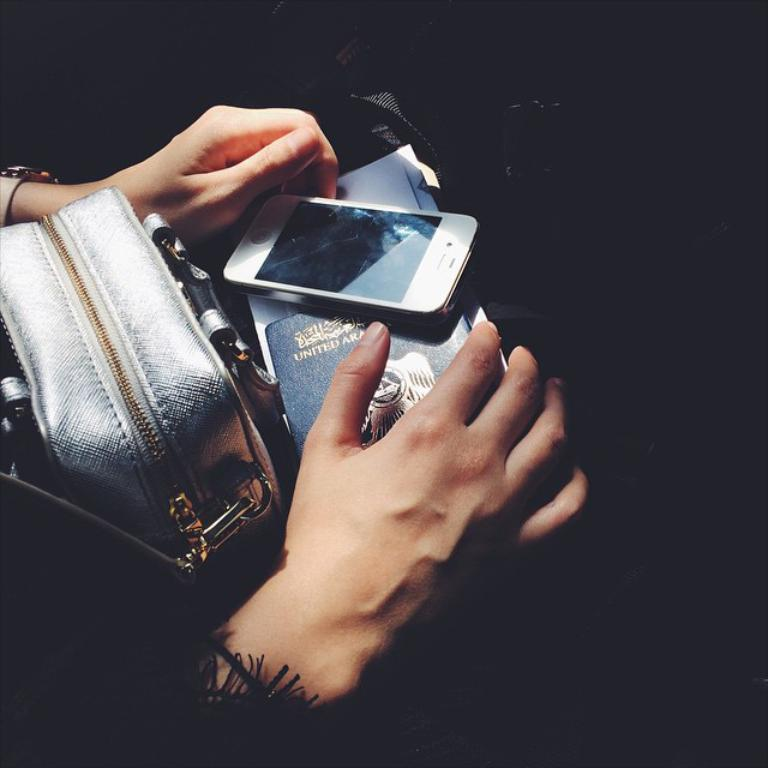What body parts are visible in the image? There are persons' hands visible in the image. What object is present that might be used for carrying items? There is a bag visible in the image. What type of device is visible in the image? There is a mobile visible in the image. What item is visible that might be used for reading or learning? There is a book visible in the image. What type of nut is being cracked by the crow in the image? There is no crow or nut present in the image. What form is the mobile taking in the image? The mobile is not taking any specific form in the image; it is simply a device visible in the image. 